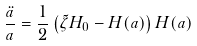<formula> <loc_0><loc_0><loc_500><loc_500>\frac { \ddot { a } } { a } = \frac { 1 } { 2 } \left ( \tilde { \zeta } H _ { 0 } - H ( a ) \right ) H ( a )</formula> 